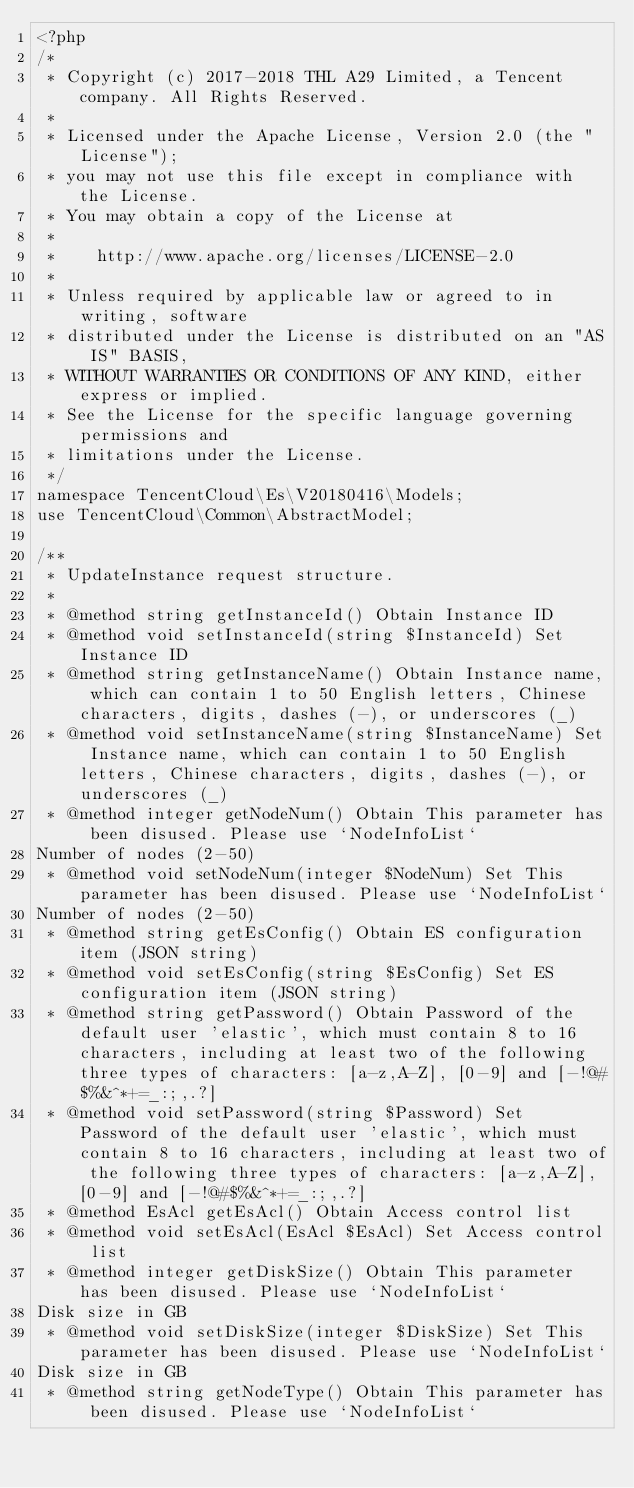Convert code to text. <code><loc_0><loc_0><loc_500><loc_500><_PHP_><?php
/*
 * Copyright (c) 2017-2018 THL A29 Limited, a Tencent company. All Rights Reserved.
 *
 * Licensed under the Apache License, Version 2.0 (the "License");
 * you may not use this file except in compliance with the License.
 * You may obtain a copy of the License at
 *
 *    http://www.apache.org/licenses/LICENSE-2.0
 *
 * Unless required by applicable law or agreed to in writing, software
 * distributed under the License is distributed on an "AS IS" BASIS,
 * WITHOUT WARRANTIES OR CONDITIONS OF ANY KIND, either express or implied.
 * See the License for the specific language governing permissions and
 * limitations under the License.
 */
namespace TencentCloud\Es\V20180416\Models;
use TencentCloud\Common\AbstractModel;

/**
 * UpdateInstance request structure.
 *
 * @method string getInstanceId() Obtain Instance ID
 * @method void setInstanceId(string $InstanceId) Set Instance ID
 * @method string getInstanceName() Obtain Instance name, which can contain 1 to 50 English letters, Chinese characters, digits, dashes (-), or underscores (_)
 * @method void setInstanceName(string $InstanceName) Set Instance name, which can contain 1 to 50 English letters, Chinese characters, digits, dashes (-), or underscores (_)
 * @method integer getNodeNum() Obtain This parameter has been disused. Please use `NodeInfoList`
Number of nodes (2-50)
 * @method void setNodeNum(integer $NodeNum) Set This parameter has been disused. Please use `NodeInfoList`
Number of nodes (2-50)
 * @method string getEsConfig() Obtain ES configuration item (JSON string)
 * @method void setEsConfig(string $EsConfig) Set ES configuration item (JSON string)
 * @method string getPassword() Obtain Password of the default user 'elastic', which must contain 8 to 16 characters, including at least two of the following three types of characters: [a-z,A-Z], [0-9] and [-!@#$%&^*+=_:;,.?]
 * @method void setPassword(string $Password) Set Password of the default user 'elastic', which must contain 8 to 16 characters, including at least two of the following three types of characters: [a-z,A-Z], [0-9] and [-!@#$%&^*+=_:;,.?]
 * @method EsAcl getEsAcl() Obtain Access control list
 * @method void setEsAcl(EsAcl $EsAcl) Set Access control list
 * @method integer getDiskSize() Obtain This parameter has been disused. Please use `NodeInfoList`
Disk size in GB
 * @method void setDiskSize(integer $DiskSize) Set This parameter has been disused. Please use `NodeInfoList`
Disk size in GB
 * @method string getNodeType() Obtain This parameter has been disused. Please use `NodeInfoList`</code> 